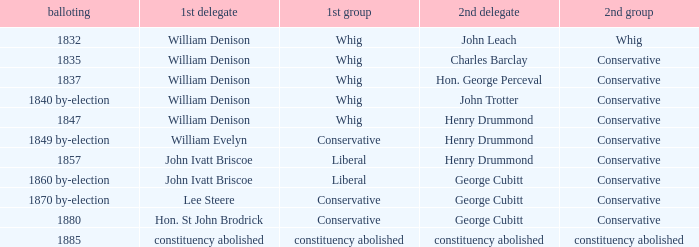Which party's 1st member is William Denison in the election of 1832? Whig. 